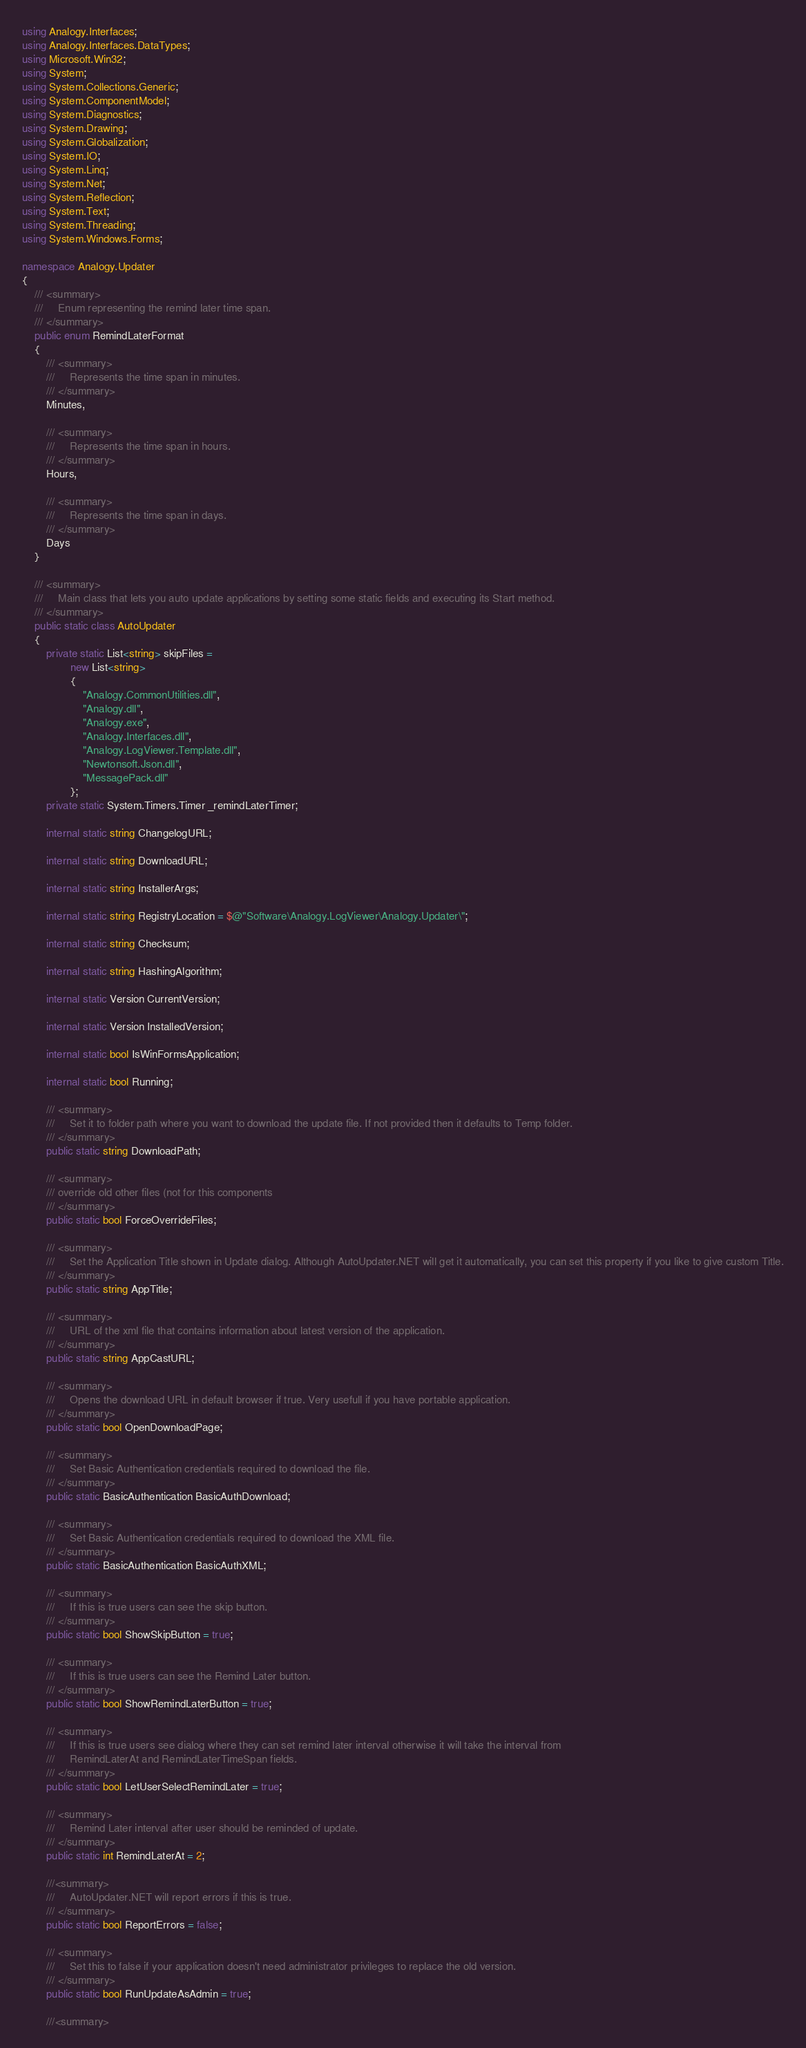<code> <loc_0><loc_0><loc_500><loc_500><_C#_>using Analogy.Interfaces;
using Analogy.Interfaces.DataTypes;
using Microsoft.Win32;
using System;
using System.Collections.Generic;
using System.ComponentModel;
using System.Diagnostics;
using System.Drawing;
using System.Globalization;
using System.IO;
using System.Linq;
using System.Net;
using System.Reflection;
using System.Text;
using System.Threading;
using System.Windows.Forms;

namespace Analogy.Updater
{
    /// <summary>
    ///     Enum representing the remind later time span.
    /// </summary>
    public enum RemindLaterFormat
    {
        /// <summary>
        ///     Represents the time span in minutes.
        /// </summary>
        Minutes,

        /// <summary>
        ///     Represents the time span in hours.
        /// </summary>
        Hours,

        /// <summary>
        ///     Represents the time span in days.
        /// </summary>
        Days
    }

    /// <summary>
    ///     Main class that lets you auto update applications by setting some static fields and executing its Start method.
    /// </summary>
    public static class AutoUpdater
    {
        private static List<string> skipFiles =
                new List<string>
                {
                    "Analogy.CommonUtilities.dll",
                    "Analogy.dll",
                    "Analogy.exe",
                    "Analogy.Interfaces.dll",
                    "Analogy.LogViewer.Template.dll",
                    "Newtonsoft.Json.dll",
                    "MessagePack.dll"
                };
        private static System.Timers.Timer _remindLaterTimer;

        internal static string ChangelogURL;

        internal static string DownloadURL;

        internal static string InstallerArgs;

        internal static string RegistryLocation = $@"Software\Analogy.LogViewer\Analogy.Updater\";

        internal static string Checksum;

        internal static string HashingAlgorithm;

        internal static Version CurrentVersion;

        internal static Version InstalledVersion;

        internal static bool IsWinFormsApplication;

        internal static bool Running;

        /// <summary>
        ///     Set it to folder path where you want to download the update file. If not provided then it defaults to Temp folder.
        /// </summary>
        public static string DownloadPath;

        /// <summary>
        /// override old other files (not for this components
        /// </summary>
        public static bool ForceOverrideFiles;

        /// <summary>
        ///     Set the Application Title shown in Update dialog. Although AutoUpdater.NET will get it automatically, you can set this property if you like to give custom Title.
        /// </summary>
        public static string AppTitle;

        /// <summary>
        ///     URL of the xml file that contains information about latest version of the application.
        /// </summary>
        public static string AppCastURL;

        /// <summary>
        ///     Opens the download URL in default browser if true. Very usefull if you have portable application.
        /// </summary>
        public static bool OpenDownloadPage;

        /// <summary>
        ///     Set Basic Authentication credentials required to download the file.
        /// </summary>
        public static BasicAuthentication BasicAuthDownload;

        /// <summary>
        ///     Set Basic Authentication credentials required to download the XML file.
        /// </summary>
        public static BasicAuthentication BasicAuthXML;

        /// <summary>
        ///     If this is true users can see the skip button.
        /// </summary>
        public static bool ShowSkipButton = true;

        /// <summary>
        ///     If this is true users can see the Remind Later button.
        /// </summary>
        public static bool ShowRemindLaterButton = true;

        /// <summary>
        ///     If this is true users see dialog where they can set remind later interval otherwise it will take the interval from
        ///     RemindLaterAt and RemindLaterTimeSpan fields.
        /// </summary>
        public static bool LetUserSelectRemindLater = true;

        /// <summary>
        ///     Remind Later interval after user should be reminded of update.
        /// </summary>
        public static int RemindLaterAt = 2;

        ///<summary>
        ///     AutoUpdater.NET will report errors if this is true.
        /// </summary>
        public static bool ReportErrors = false;

        /// <summary>
        ///     Set this to false if your application doesn't need administrator privileges to replace the old version.
        /// </summary>
        public static bool RunUpdateAsAdmin = true;

        ///<summary></code> 